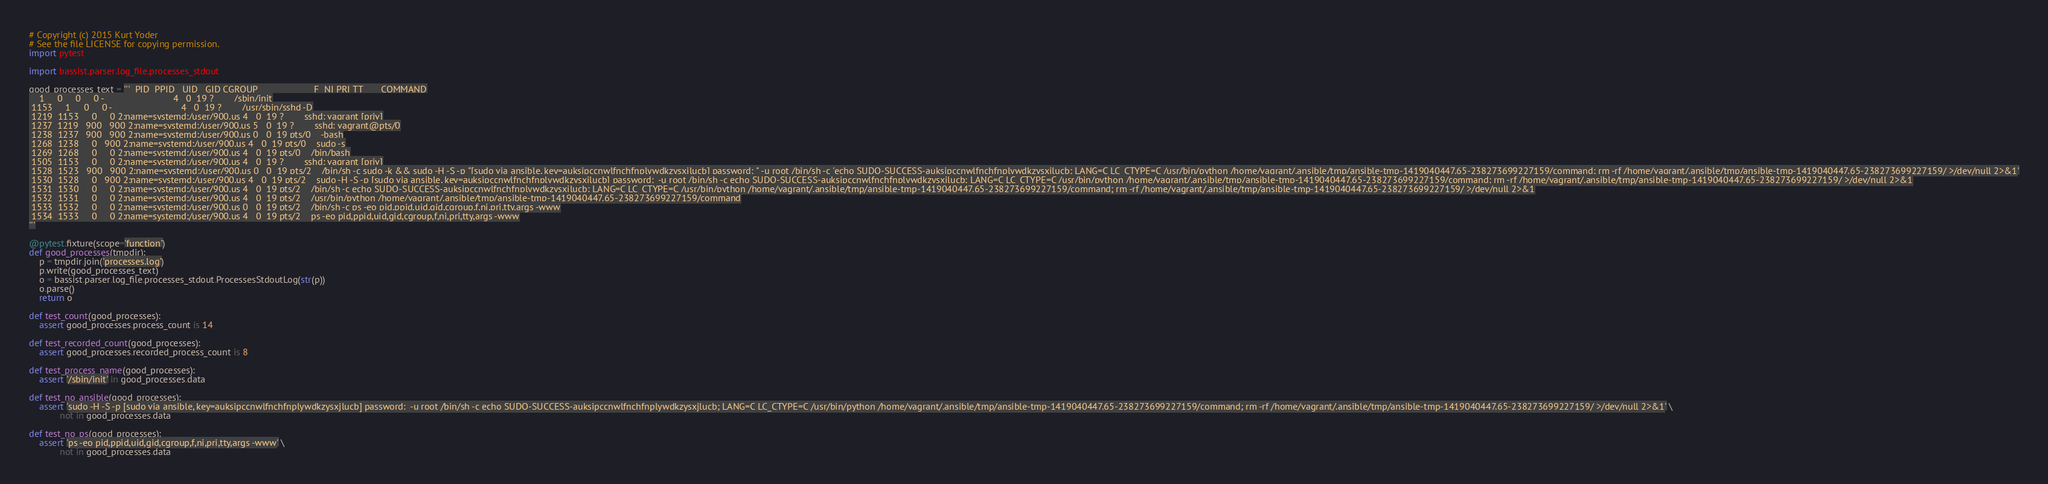<code> <loc_0><loc_0><loc_500><loc_500><_Python_># Copyright (c) 2015 Kurt Yoder
# See the file LICENSE for copying permission.
import pytest

import bassist.parser.log_file.processes_stdout

good_processes_text = '''  PID  PPID   UID   GID CGROUP                      F  NI PRI TT       COMMAND
    1     0     0     0 -                           4   0  19 ?        /sbin/init
 1153     1     0     0 -                           4   0  19 ?        /usr/sbin/sshd -D
 1219  1153     0     0 2:name=systemd:/user/900.us 4   0  19 ?        sshd: vagrant [priv]
 1237  1219   900   900 2:name=systemd:/user/900.us 5   0  19 ?        sshd: vagrant@pts/0
 1238  1237   900   900 2:name=systemd:/user/900.us 0   0  19 pts/0    -bash
 1268  1238     0   900 2:name=systemd:/user/900.us 4   0  19 pts/0    sudo -s
 1269  1268     0     0 2:name=systemd:/user/900.us 4   0  19 pts/0    /bin/bash
 1505  1153     0     0 2:name=systemd:/user/900.us 4   0  19 ?        sshd: vagrant [priv]
 1528  1523   900   900 2:name=systemd:/user/900.us 0   0  19 pts/2    /bin/sh -c sudo -k && sudo -H -S -p "[sudo via ansible, key=auksipccnwlfnchfnplywdkzysxjlucb] password: " -u root /bin/sh -c 'echo SUDO-SUCCESS-auksipccnwlfnchfnplywdkzysxjlucb; LANG=C LC_CTYPE=C /usr/bin/python /home/vagrant/.ansible/tmp/ansible-tmp-1419040447.65-238273699227159/command; rm -rf /home/vagrant/.ansible/tmp/ansible-tmp-1419040447.65-238273699227159/ >/dev/null 2>&1'
 1530  1528     0   900 2:name=systemd:/user/900.us 4   0  19 pts/2    sudo -H -S -p [sudo via ansible, key=auksipccnwlfnchfnplywdkzysxjlucb] password:  -u root /bin/sh -c echo SUDO-SUCCESS-auksipccnwlfnchfnplywdkzysxjlucb; LANG=C LC_CTYPE=C /usr/bin/python /home/vagrant/.ansible/tmp/ansible-tmp-1419040447.65-238273699227159/command; rm -rf /home/vagrant/.ansible/tmp/ansible-tmp-1419040447.65-238273699227159/ >/dev/null 2>&1
 1531  1530     0     0 2:name=systemd:/user/900.us 4   0  19 pts/2    /bin/sh -c echo SUDO-SUCCESS-auksipccnwlfnchfnplywdkzysxjlucb; LANG=C LC_CTYPE=C /usr/bin/python /home/vagrant/.ansible/tmp/ansible-tmp-1419040447.65-238273699227159/command; rm -rf /home/vagrant/.ansible/tmp/ansible-tmp-1419040447.65-238273699227159/ >/dev/null 2>&1
 1532  1531     0     0 2:name=systemd:/user/900.us 4   0  19 pts/2    /usr/bin/python /home/vagrant/.ansible/tmp/ansible-tmp-1419040447.65-238273699227159/command
 1533  1532     0     0 2:name=systemd:/user/900.us 0   0  19 pts/2    /bin/sh -c ps -eo pid,ppid,uid,gid,cgroup,f,ni,pri,tty,args -www
 1534  1533     0     0 2:name=systemd:/user/900.us 4   0  19 pts/2    ps -eo pid,ppid,uid,gid,cgroup,f,ni,pri,tty,args -www
'''

@pytest.fixture(scope='function')
def good_processes(tmpdir):
    p = tmpdir.join('processes.log')
    p.write(good_processes_text)
    o = bassist.parser.log_file.processes_stdout.ProcessesStdoutLog(str(p))
    o.parse()
    return o

def test_count(good_processes):
    assert good_processes.process_count is 14

def test_recorded_count(good_processes):
    assert good_processes.recorded_process_count is 8

def test_process_name(good_processes):
    assert '/sbin/init' in good_processes.data

def test_no_ansible(good_processes):
    assert 'sudo -H -S -p [sudo via ansible, key=auksipccnwlfnchfnplywdkzysxjlucb] password:  -u root /bin/sh -c echo SUDO-SUCCESS-auksipccnwlfnchfnplywdkzysxjlucb; LANG=C LC_CTYPE=C /usr/bin/python /home/vagrant/.ansible/tmp/ansible-tmp-1419040447.65-238273699227159/command; rm -rf /home/vagrant/.ansible/tmp/ansible-tmp-1419040447.65-238273699227159/ >/dev/null 2>&1' \
            not in good_processes.data

def test_no_ps(good_processes):
    assert 'ps -eo pid,ppid,uid,gid,cgroup,f,ni,pri,tty,args -www' \
            not in good_processes.data
</code> 